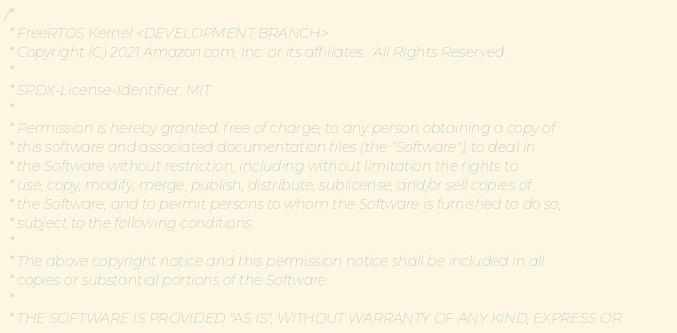<code> <loc_0><loc_0><loc_500><loc_500><_C_>/*
 * FreeRTOS Kernel <DEVELOPMENT BRANCH>
 * Copyright (C) 2021 Amazon.com, Inc. or its affiliates.  All Rights Reserved.
 *
 * SPDX-License-Identifier: MIT
 *
 * Permission is hereby granted, free of charge, to any person obtaining a copy of
 * this software and associated documentation files (the "Software"), to deal in
 * the Software without restriction, including without limitation the rights to
 * use, copy, modify, merge, publish, distribute, sublicense, and/or sell copies of
 * the Software, and to permit persons to whom the Software is furnished to do so,
 * subject to the following conditions:
 *
 * The above copyright notice and this permission notice shall be included in all
 * copies or substantial portions of the Software.
 *
 * THE SOFTWARE IS PROVIDED "AS IS", WITHOUT WARRANTY OF ANY KIND, EXPRESS OR</code> 